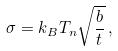Convert formula to latex. <formula><loc_0><loc_0><loc_500><loc_500>\sigma = k _ { B } T _ { n } \sqrt { \frac { b } { t } } \, ,</formula> 